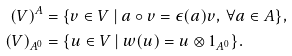Convert formula to latex. <formula><loc_0><loc_0><loc_500><loc_500>( V ) ^ { A } & = \{ v \in V \ | \ a \circ v = \epsilon ( a ) v , \ \forall a \in A \} , \\ ( V ) _ { A ^ { 0 } } & = \{ u \in V \ | \ w ( u ) = u \otimes 1 _ { A ^ { 0 } } \} .</formula> 